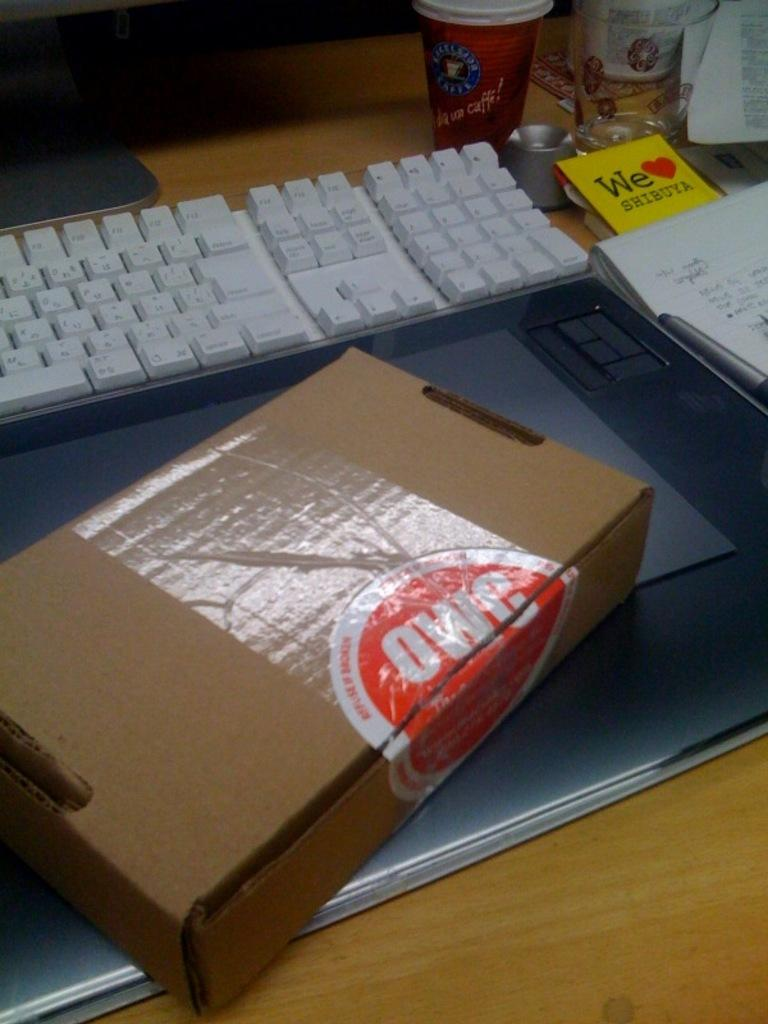Provide a one-sentence caption for the provided image. A cardboard box with label "OWC" next to a keyboard. 